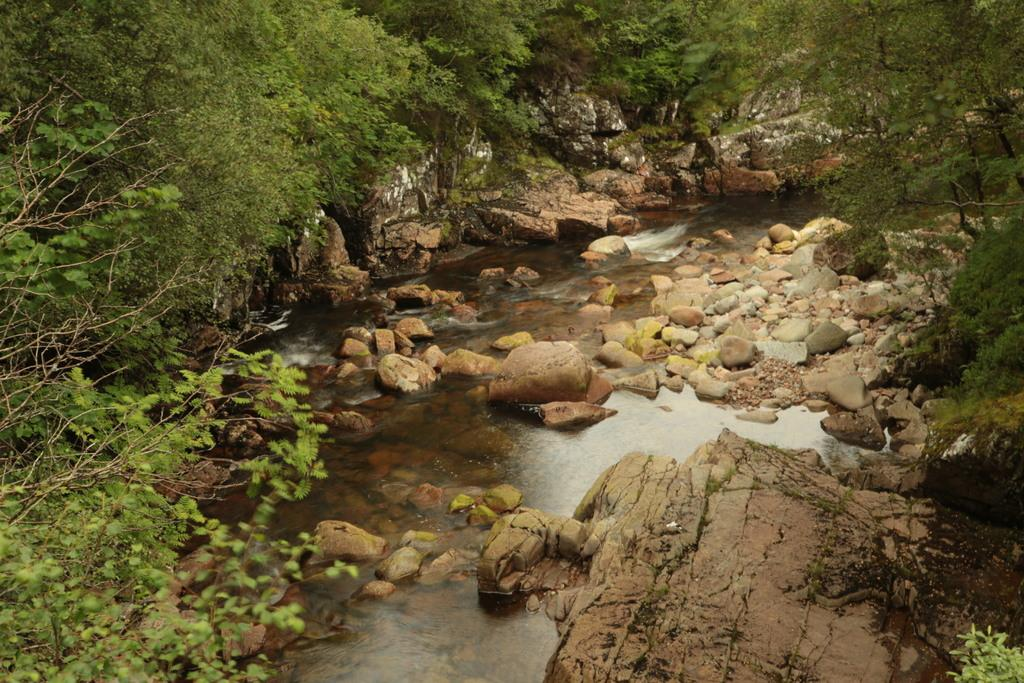What is the primary element visible in the image? There is water in the image. What other objects or features can be seen in the image? There are rocks, plants, and trees in the image. What is the price of the bag seen in the image? There is no bag present in the image, so it is not possible to determine its price. 